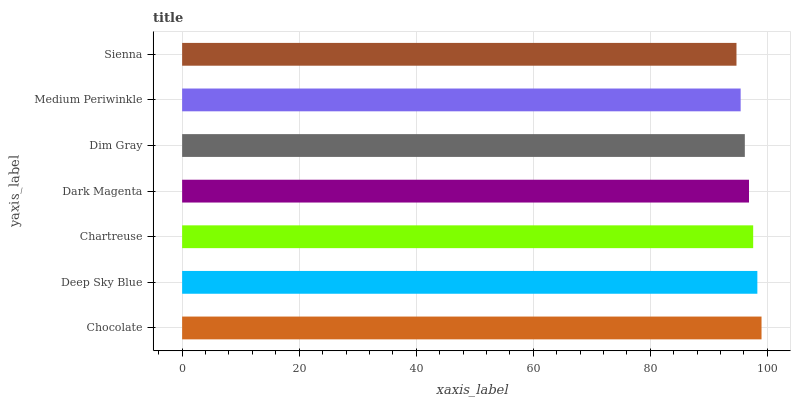Is Sienna the minimum?
Answer yes or no. Yes. Is Chocolate the maximum?
Answer yes or no. Yes. Is Deep Sky Blue the minimum?
Answer yes or no. No. Is Deep Sky Blue the maximum?
Answer yes or no. No. Is Chocolate greater than Deep Sky Blue?
Answer yes or no. Yes. Is Deep Sky Blue less than Chocolate?
Answer yes or no. Yes. Is Deep Sky Blue greater than Chocolate?
Answer yes or no. No. Is Chocolate less than Deep Sky Blue?
Answer yes or no. No. Is Dark Magenta the high median?
Answer yes or no. Yes. Is Dark Magenta the low median?
Answer yes or no. Yes. Is Deep Sky Blue the high median?
Answer yes or no. No. Is Sienna the low median?
Answer yes or no. No. 